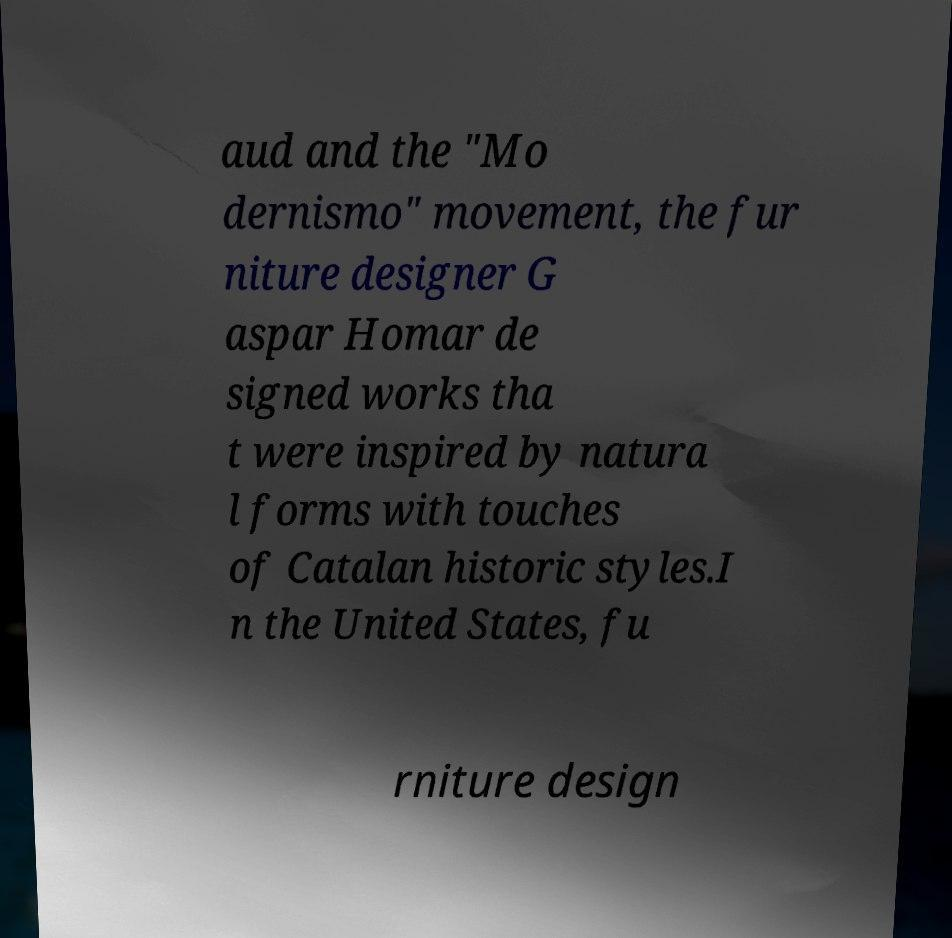Please identify and transcribe the text found in this image. aud and the "Mo dernismo" movement, the fur niture designer G aspar Homar de signed works tha t were inspired by natura l forms with touches of Catalan historic styles.I n the United States, fu rniture design 